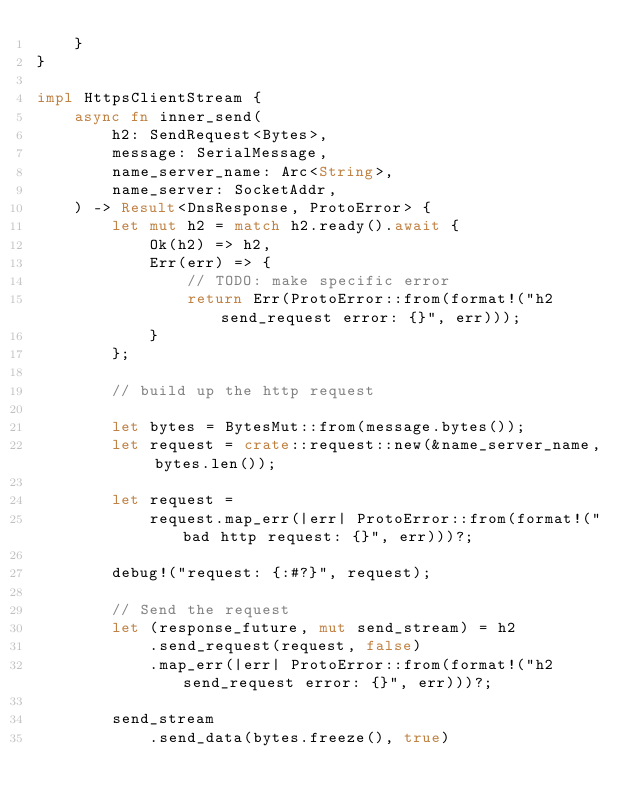Convert code to text. <code><loc_0><loc_0><loc_500><loc_500><_Rust_>    }
}

impl HttpsClientStream {
    async fn inner_send(
        h2: SendRequest<Bytes>,
        message: SerialMessage,
        name_server_name: Arc<String>,
        name_server: SocketAddr,
    ) -> Result<DnsResponse, ProtoError> {
        let mut h2 = match h2.ready().await {
            Ok(h2) => h2,
            Err(err) => {
                // TODO: make specific error
                return Err(ProtoError::from(format!("h2 send_request error: {}", err)));
            }
        };

        // build up the http request

        let bytes = BytesMut::from(message.bytes());
        let request = crate::request::new(&name_server_name, bytes.len());

        let request =
            request.map_err(|err| ProtoError::from(format!("bad http request: {}", err)))?;

        debug!("request: {:#?}", request);

        // Send the request
        let (response_future, mut send_stream) = h2
            .send_request(request, false)
            .map_err(|err| ProtoError::from(format!("h2 send_request error: {}", err)))?;

        send_stream
            .send_data(bytes.freeze(), true)</code> 